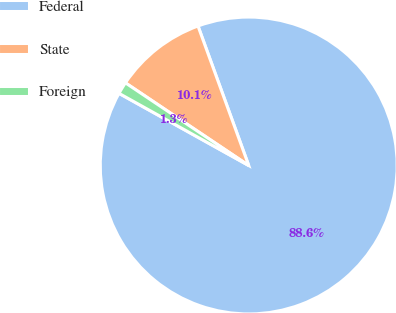Convert chart. <chart><loc_0><loc_0><loc_500><loc_500><pie_chart><fcel>Federal<fcel>State<fcel>Foreign<nl><fcel>88.62%<fcel>10.05%<fcel>1.32%<nl></chart> 